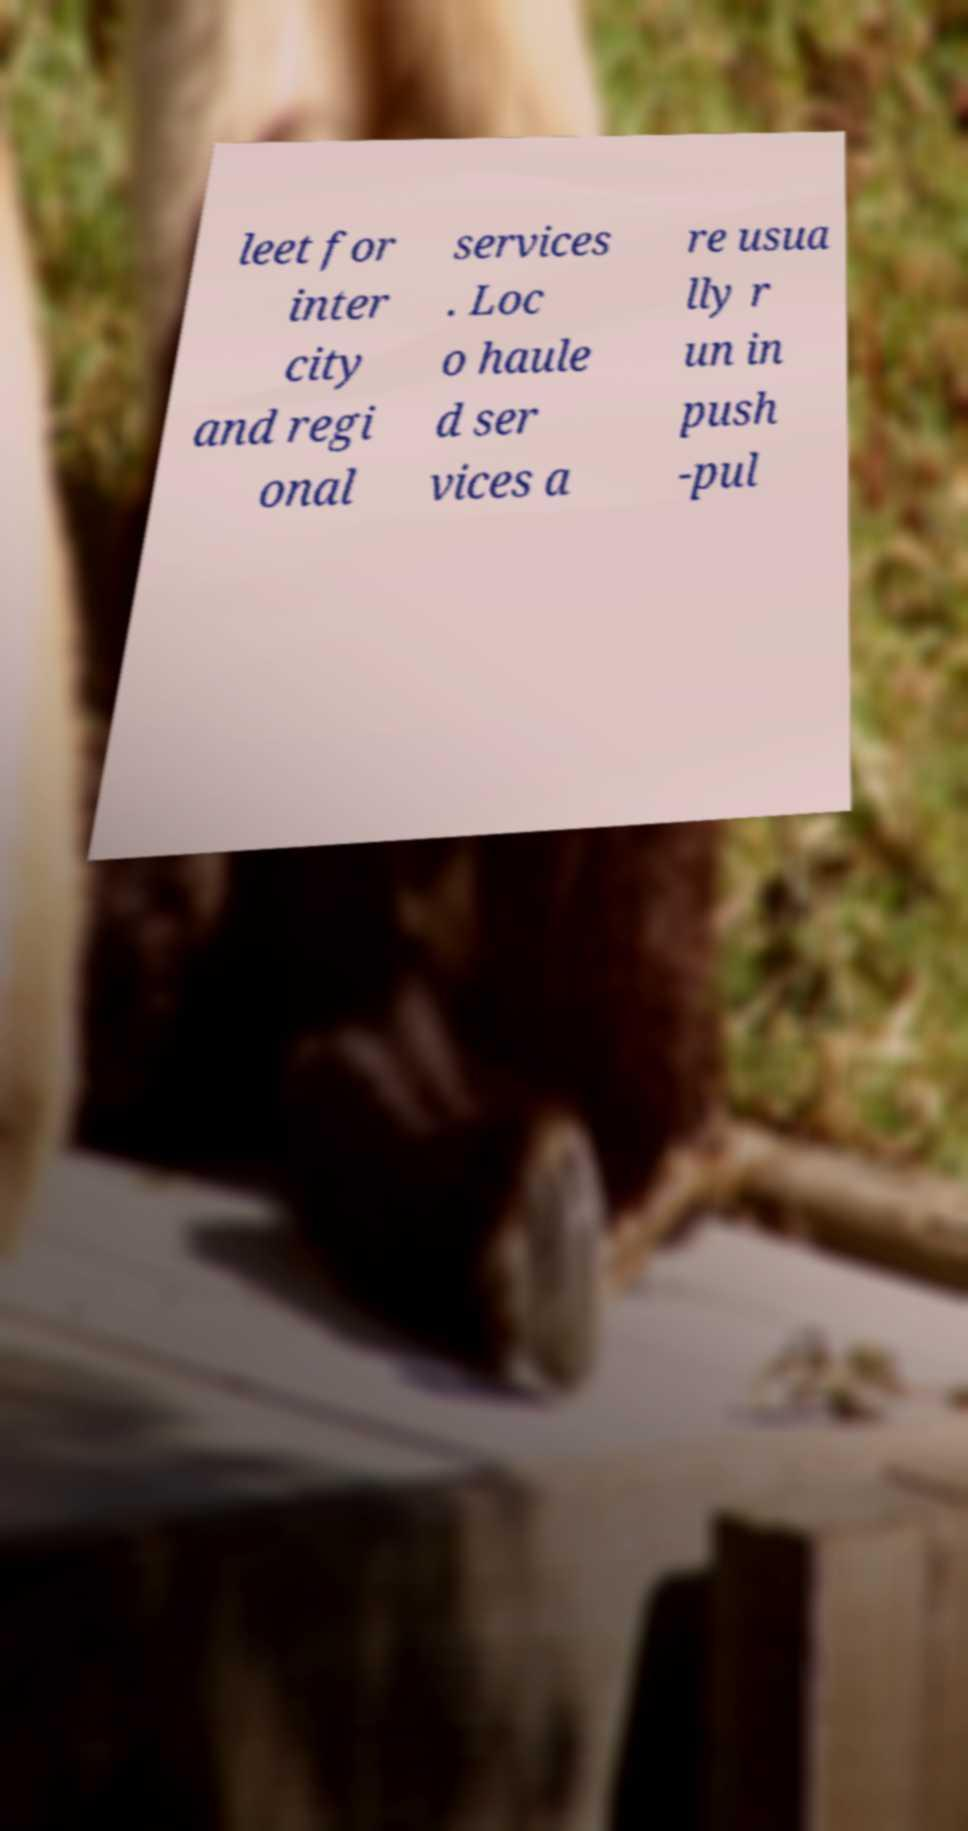Please identify and transcribe the text found in this image. leet for inter city and regi onal services . Loc o haule d ser vices a re usua lly r un in push -pul 